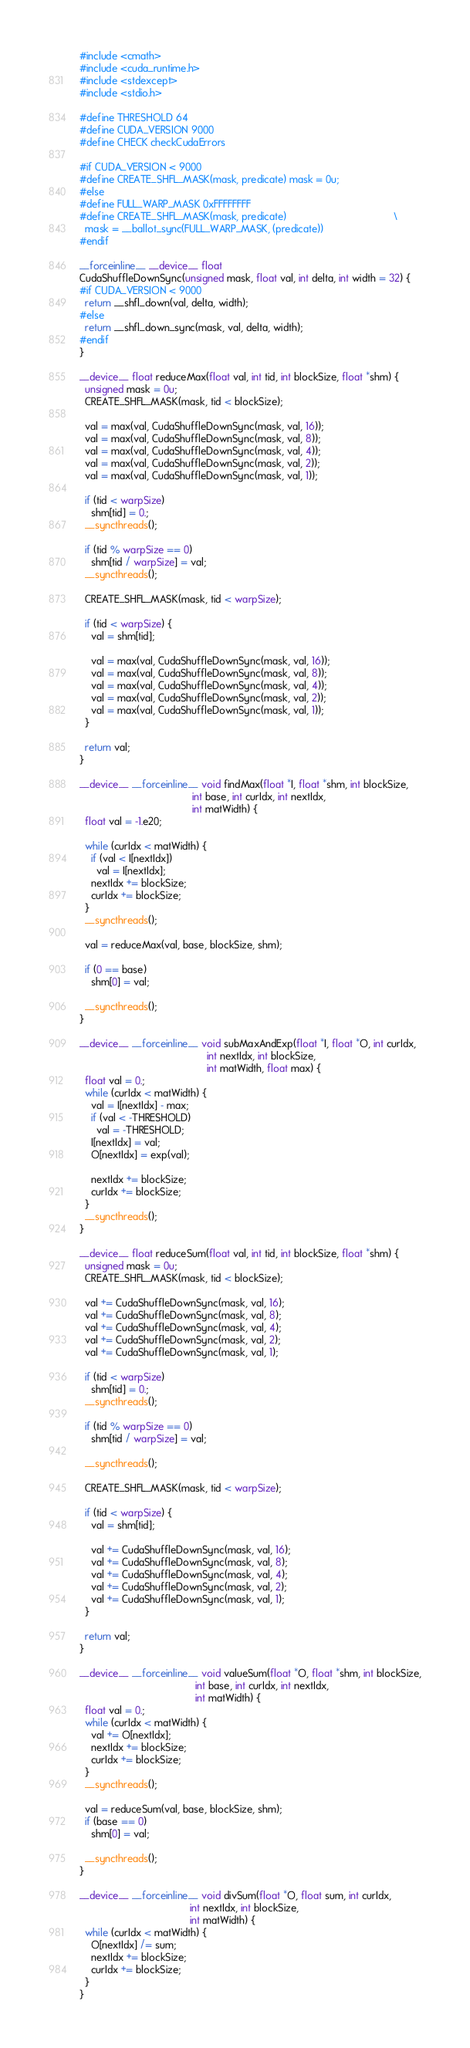Convert code to text. <code><loc_0><loc_0><loc_500><loc_500><_Cuda_>#include <cmath>
#include <cuda_runtime.h>
#include <stdexcept>
#include <stdio.h>

#define THRESHOLD 64
#define CUDA_VERSION 9000
#define CHECK checkCudaErrors

#if CUDA_VERSION < 9000
#define CREATE_SHFL_MASK(mask, predicate) mask = 0u;
#else
#define FULL_WARP_MASK 0xFFFFFFFF
#define CREATE_SHFL_MASK(mask, predicate)                                      \
  mask = __ballot_sync(FULL_WARP_MASK, (predicate))
#endif

__forceinline__ __device__ float
CudaShuffleDownSync(unsigned mask, float val, int delta, int width = 32) {
#if CUDA_VERSION < 9000
  return __shfl_down(val, delta, width);
#else
  return __shfl_down_sync(mask, val, delta, width);
#endif
}

__device__ float reduceMax(float val, int tid, int blockSize, float *shm) {
  unsigned mask = 0u;
  CREATE_SHFL_MASK(mask, tid < blockSize);

  val = max(val, CudaShuffleDownSync(mask, val, 16));
  val = max(val, CudaShuffleDownSync(mask, val, 8));
  val = max(val, CudaShuffleDownSync(mask, val, 4));
  val = max(val, CudaShuffleDownSync(mask, val, 2));
  val = max(val, CudaShuffleDownSync(mask, val, 1));

  if (tid < warpSize)
    shm[tid] = 0.;
  __syncthreads();

  if (tid % warpSize == 0)
    shm[tid / warpSize] = val;
  __syncthreads();

  CREATE_SHFL_MASK(mask, tid < warpSize);

  if (tid < warpSize) {
    val = shm[tid];

    val = max(val, CudaShuffleDownSync(mask, val, 16));
    val = max(val, CudaShuffleDownSync(mask, val, 8));
    val = max(val, CudaShuffleDownSync(mask, val, 4));
    val = max(val, CudaShuffleDownSync(mask, val, 2));
    val = max(val, CudaShuffleDownSync(mask, val, 1));
  }

  return val;
}

__device__ __forceinline__ void findMax(float *I, float *shm, int blockSize,
                                        int base, int curIdx, int nextIdx,
                                        int matWidth) {
  float val = -1.e20;

  while (curIdx < matWidth) {
    if (val < I[nextIdx])
      val = I[nextIdx];
    nextIdx += blockSize;
    curIdx += blockSize;
  }
  __syncthreads();

  val = reduceMax(val, base, blockSize, shm);

  if (0 == base)
    shm[0] = val;

  __syncthreads();
}

__device__ __forceinline__ void subMaxAndExp(float *I, float *O, int curIdx,
                                             int nextIdx, int blockSize,
                                             int matWidth, float max) {
  float val = 0.;
  while (curIdx < matWidth) {
    val = I[nextIdx] - max;
    if (val < -THRESHOLD)
      val = -THRESHOLD;
    I[nextIdx] = val;
    O[nextIdx] = exp(val);

    nextIdx += blockSize;
    curIdx += blockSize;
  }
  __syncthreads();
}

__device__ float reduceSum(float val, int tid, int blockSize, float *shm) {
  unsigned mask = 0u;
  CREATE_SHFL_MASK(mask, tid < blockSize);

  val += CudaShuffleDownSync(mask, val, 16);
  val += CudaShuffleDownSync(mask, val, 8);
  val += CudaShuffleDownSync(mask, val, 4);
  val += CudaShuffleDownSync(mask, val, 2);
  val += CudaShuffleDownSync(mask, val, 1);

  if (tid < warpSize)
    shm[tid] = 0.;
  __syncthreads();

  if (tid % warpSize == 0)
    shm[tid / warpSize] = val;

  __syncthreads();

  CREATE_SHFL_MASK(mask, tid < warpSize);

  if (tid < warpSize) {
    val = shm[tid];

    val += CudaShuffleDownSync(mask, val, 16);
    val += CudaShuffleDownSync(mask, val, 8);
    val += CudaShuffleDownSync(mask, val, 4);
    val += CudaShuffleDownSync(mask, val, 2);
    val += CudaShuffleDownSync(mask, val, 1);
  }

  return val;
}

__device__ __forceinline__ void valueSum(float *O, float *shm, int blockSize,
                                         int base, int curIdx, int nextIdx,
                                         int matWidth) {
  float val = 0.;
  while (curIdx < matWidth) {
    val += O[nextIdx];
    nextIdx += blockSize;
    curIdx += blockSize;
  }
  __syncthreads();

  val = reduceSum(val, base, blockSize, shm);
  if (base == 0)
    shm[0] = val;

  __syncthreads();
}

__device__ __forceinline__ void divSum(float *O, float sum, int curIdx,
                                       int nextIdx, int blockSize,
                                       int matWidth) {
  while (curIdx < matWidth) {
    O[nextIdx] /= sum;
    nextIdx += blockSize;
    curIdx += blockSize;
  }
}
</code> 